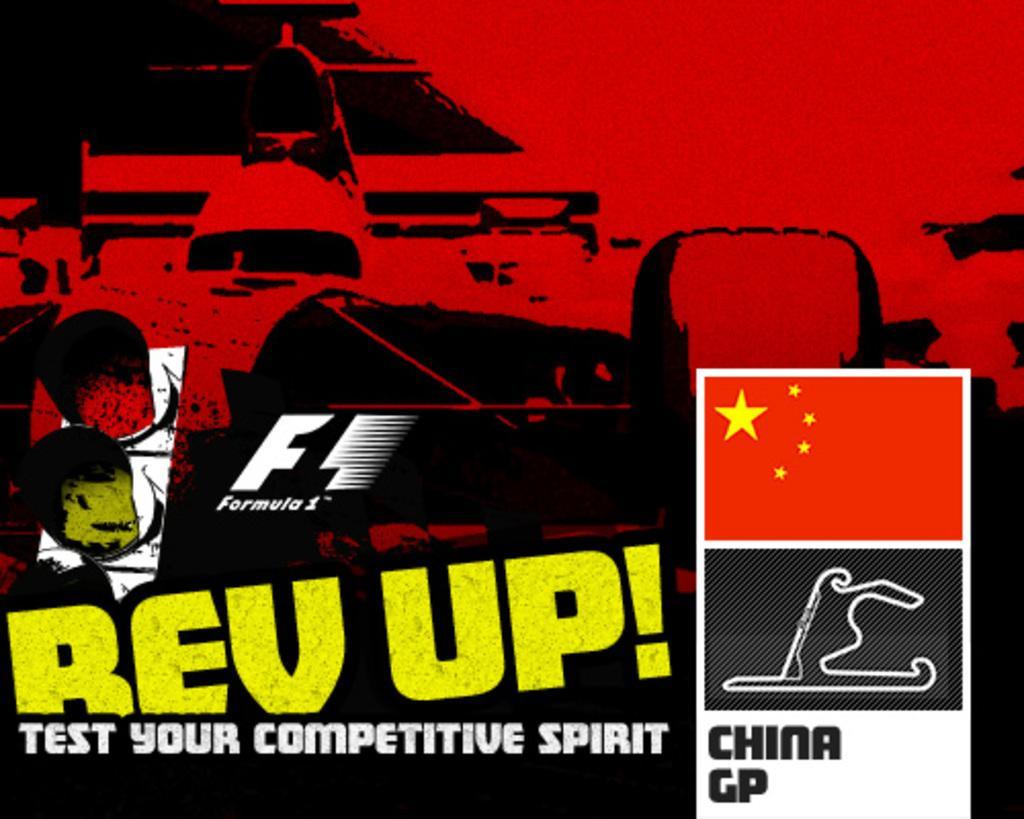Can you describe this image briefly? In this image there is a poster with some text and graphic images on it. 